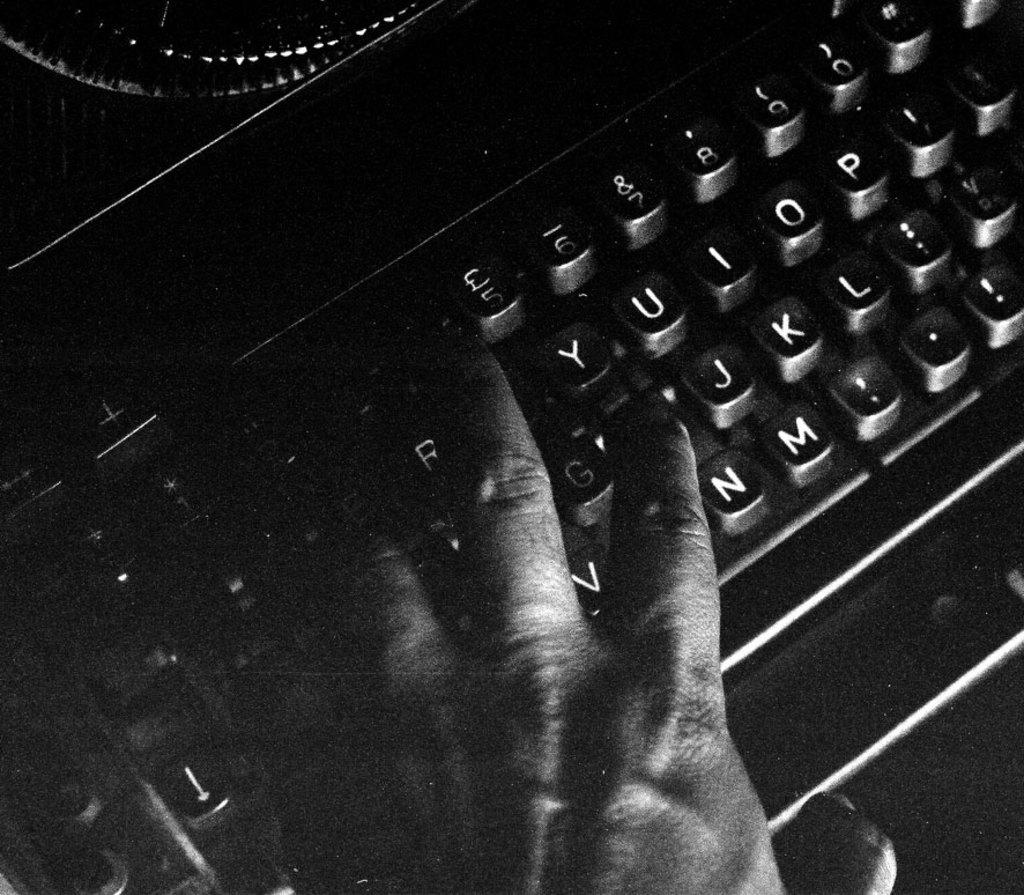What is the main subject of the image? There is a person in the image. What is the person doing in the image? The person's hand is on a keyboard. Can you describe the background of the image? The background of the image is dark. What type of faucet can be seen near the seashore in the image? There is no faucet or seashore present in the image; it features a person with their hand on a keyboard and a dark background. 